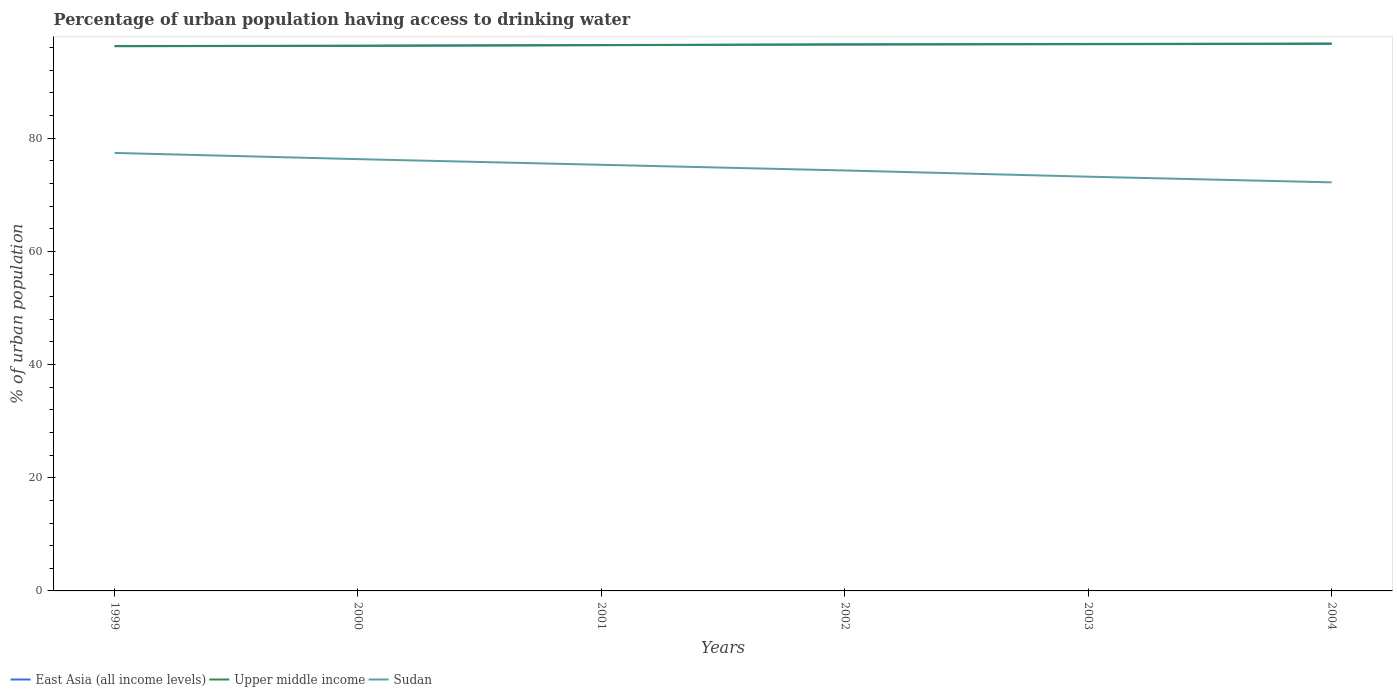How many different coloured lines are there?
Offer a very short reply. 3. Across all years, what is the maximum percentage of urban population having access to drinking water in East Asia (all income levels)?
Your answer should be very brief. 96.29. What is the total percentage of urban population having access to drinking water in East Asia (all income levels) in the graph?
Provide a succinct answer. -0.05. What is the difference between the highest and the second highest percentage of urban population having access to drinking water in Sudan?
Give a very brief answer. 5.2. What is the difference between the highest and the lowest percentage of urban population having access to drinking water in Upper middle income?
Your answer should be compact. 3. Is the percentage of urban population having access to drinking water in Sudan strictly greater than the percentage of urban population having access to drinking water in Upper middle income over the years?
Your response must be concise. Yes. How many years are there in the graph?
Provide a short and direct response. 6. How many legend labels are there?
Your response must be concise. 3. How are the legend labels stacked?
Keep it short and to the point. Horizontal. What is the title of the graph?
Your answer should be compact. Percentage of urban population having access to drinking water. Does "China" appear as one of the legend labels in the graph?
Your answer should be compact. No. What is the label or title of the X-axis?
Provide a succinct answer. Years. What is the label or title of the Y-axis?
Your answer should be very brief. % of urban population. What is the % of urban population in East Asia (all income levels) in 1999?
Make the answer very short. 96.29. What is the % of urban population in Upper middle income in 1999?
Offer a very short reply. 96.25. What is the % of urban population in Sudan in 1999?
Offer a terse response. 77.4. What is the % of urban population of East Asia (all income levels) in 2000?
Your answer should be compact. 96.35. What is the % of urban population in Upper middle income in 2000?
Make the answer very short. 96.32. What is the % of urban population of Sudan in 2000?
Your answer should be very brief. 76.3. What is the % of urban population in East Asia (all income levels) in 2001?
Make the answer very short. 96.47. What is the % of urban population in Upper middle income in 2001?
Ensure brevity in your answer.  96.43. What is the % of urban population of Sudan in 2001?
Ensure brevity in your answer.  75.3. What is the % of urban population in East Asia (all income levels) in 2002?
Your response must be concise. 96.54. What is the % of urban population of Upper middle income in 2002?
Offer a terse response. 96.6. What is the % of urban population in Sudan in 2002?
Your response must be concise. 74.3. What is the % of urban population of East Asia (all income levels) in 2003?
Keep it short and to the point. 96.61. What is the % of urban population in Upper middle income in 2003?
Give a very brief answer. 96.66. What is the % of urban population in Sudan in 2003?
Your response must be concise. 73.2. What is the % of urban population in East Asia (all income levels) in 2004?
Your answer should be very brief. 96.67. What is the % of urban population in Upper middle income in 2004?
Your answer should be compact. 96.73. What is the % of urban population of Sudan in 2004?
Give a very brief answer. 72.2. Across all years, what is the maximum % of urban population in East Asia (all income levels)?
Offer a terse response. 96.67. Across all years, what is the maximum % of urban population in Upper middle income?
Make the answer very short. 96.73. Across all years, what is the maximum % of urban population of Sudan?
Give a very brief answer. 77.4. Across all years, what is the minimum % of urban population of East Asia (all income levels)?
Your response must be concise. 96.29. Across all years, what is the minimum % of urban population in Upper middle income?
Provide a succinct answer. 96.25. Across all years, what is the minimum % of urban population in Sudan?
Provide a succinct answer. 72.2. What is the total % of urban population of East Asia (all income levels) in the graph?
Offer a very short reply. 578.93. What is the total % of urban population of Upper middle income in the graph?
Your answer should be compact. 578.99. What is the total % of urban population in Sudan in the graph?
Your answer should be compact. 448.7. What is the difference between the % of urban population of East Asia (all income levels) in 1999 and that in 2000?
Keep it short and to the point. -0.05. What is the difference between the % of urban population of Upper middle income in 1999 and that in 2000?
Give a very brief answer. -0.07. What is the difference between the % of urban population of Sudan in 1999 and that in 2000?
Keep it short and to the point. 1.1. What is the difference between the % of urban population in East Asia (all income levels) in 1999 and that in 2001?
Offer a very short reply. -0.17. What is the difference between the % of urban population in Upper middle income in 1999 and that in 2001?
Provide a succinct answer. -0.18. What is the difference between the % of urban population in East Asia (all income levels) in 1999 and that in 2002?
Your response must be concise. -0.25. What is the difference between the % of urban population of Upper middle income in 1999 and that in 2002?
Give a very brief answer. -0.35. What is the difference between the % of urban population in Sudan in 1999 and that in 2002?
Your answer should be very brief. 3.1. What is the difference between the % of urban population in East Asia (all income levels) in 1999 and that in 2003?
Provide a short and direct response. -0.31. What is the difference between the % of urban population of Upper middle income in 1999 and that in 2003?
Ensure brevity in your answer.  -0.41. What is the difference between the % of urban population in East Asia (all income levels) in 1999 and that in 2004?
Provide a succinct answer. -0.38. What is the difference between the % of urban population of Upper middle income in 1999 and that in 2004?
Your answer should be compact. -0.48. What is the difference between the % of urban population of East Asia (all income levels) in 2000 and that in 2001?
Offer a terse response. -0.12. What is the difference between the % of urban population in Upper middle income in 2000 and that in 2001?
Keep it short and to the point. -0.11. What is the difference between the % of urban population in Sudan in 2000 and that in 2001?
Provide a succinct answer. 1. What is the difference between the % of urban population in East Asia (all income levels) in 2000 and that in 2002?
Your answer should be compact. -0.2. What is the difference between the % of urban population in Upper middle income in 2000 and that in 2002?
Your answer should be compact. -0.27. What is the difference between the % of urban population in Sudan in 2000 and that in 2002?
Offer a terse response. 2. What is the difference between the % of urban population in East Asia (all income levels) in 2000 and that in 2003?
Offer a terse response. -0.26. What is the difference between the % of urban population of Upper middle income in 2000 and that in 2003?
Offer a terse response. -0.34. What is the difference between the % of urban population of East Asia (all income levels) in 2000 and that in 2004?
Offer a very short reply. -0.33. What is the difference between the % of urban population in Upper middle income in 2000 and that in 2004?
Give a very brief answer. -0.41. What is the difference between the % of urban population of Sudan in 2000 and that in 2004?
Offer a terse response. 4.1. What is the difference between the % of urban population of East Asia (all income levels) in 2001 and that in 2002?
Give a very brief answer. -0.07. What is the difference between the % of urban population in Upper middle income in 2001 and that in 2002?
Offer a very short reply. -0.17. What is the difference between the % of urban population in Sudan in 2001 and that in 2002?
Your answer should be very brief. 1. What is the difference between the % of urban population of East Asia (all income levels) in 2001 and that in 2003?
Make the answer very short. -0.14. What is the difference between the % of urban population of Upper middle income in 2001 and that in 2003?
Ensure brevity in your answer.  -0.23. What is the difference between the % of urban population of East Asia (all income levels) in 2001 and that in 2004?
Your response must be concise. -0.2. What is the difference between the % of urban population in Upper middle income in 2001 and that in 2004?
Provide a succinct answer. -0.3. What is the difference between the % of urban population in East Asia (all income levels) in 2002 and that in 2003?
Keep it short and to the point. -0.07. What is the difference between the % of urban population in Upper middle income in 2002 and that in 2003?
Ensure brevity in your answer.  -0.06. What is the difference between the % of urban population in East Asia (all income levels) in 2002 and that in 2004?
Offer a terse response. -0.13. What is the difference between the % of urban population of Upper middle income in 2002 and that in 2004?
Provide a succinct answer. -0.14. What is the difference between the % of urban population in East Asia (all income levels) in 2003 and that in 2004?
Give a very brief answer. -0.07. What is the difference between the % of urban population of Upper middle income in 2003 and that in 2004?
Offer a terse response. -0.07. What is the difference between the % of urban population of East Asia (all income levels) in 1999 and the % of urban population of Upper middle income in 2000?
Your answer should be very brief. -0.03. What is the difference between the % of urban population of East Asia (all income levels) in 1999 and the % of urban population of Sudan in 2000?
Your answer should be very brief. 20. What is the difference between the % of urban population of Upper middle income in 1999 and the % of urban population of Sudan in 2000?
Provide a succinct answer. 19.95. What is the difference between the % of urban population of East Asia (all income levels) in 1999 and the % of urban population of Upper middle income in 2001?
Ensure brevity in your answer.  -0.13. What is the difference between the % of urban population of East Asia (all income levels) in 1999 and the % of urban population of Sudan in 2001?
Your response must be concise. 21. What is the difference between the % of urban population of Upper middle income in 1999 and the % of urban population of Sudan in 2001?
Your answer should be compact. 20.95. What is the difference between the % of urban population of East Asia (all income levels) in 1999 and the % of urban population of Upper middle income in 2002?
Provide a short and direct response. -0.3. What is the difference between the % of urban population of East Asia (all income levels) in 1999 and the % of urban population of Sudan in 2002?
Your response must be concise. 22. What is the difference between the % of urban population in Upper middle income in 1999 and the % of urban population in Sudan in 2002?
Provide a short and direct response. 21.95. What is the difference between the % of urban population in East Asia (all income levels) in 1999 and the % of urban population in Upper middle income in 2003?
Make the answer very short. -0.37. What is the difference between the % of urban population of East Asia (all income levels) in 1999 and the % of urban population of Sudan in 2003?
Your answer should be very brief. 23.09. What is the difference between the % of urban population of Upper middle income in 1999 and the % of urban population of Sudan in 2003?
Make the answer very short. 23.05. What is the difference between the % of urban population in East Asia (all income levels) in 1999 and the % of urban population in Upper middle income in 2004?
Your answer should be compact. -0.44. What is the difference between the % of urban population in East Asia (all income levels) in 1999 and the % of urban population in Sudan in 2004?
Your answer should be very brief. 24.09. What is the difference between the % of urban population in Upper middle income in 1999 and the % of urban population in Sudan in 2004?
Your answer should be very brief. 24.05. What is the difference between the % of urban population of East Asia (all income levels) in 2000 and the % of urban population of Upper middle income in 2001?
Make the answer very short. -0.08. What is the difference between the % of urban population in East Asia (all income levels) in 2000 and the % of urban population in Sudan in 2001?
Make the answer very short. 21.05. What is the difference between the % of urban population in Upper middle income in 2000 and the % of urban population in Sudan in 2001?
Give a very brief answer. 21.02. What is the difference between the % of urban population of East Asia (all income levels) in 2000 and the % of urban population of Upper middle income in 2002?
Keep it short and to the point. -0.25. What is the difference between the % of urban population of East Asia (all income levels) in 2000 and the % of urban population of Sudan in 2002?
Offer a very short reply. 22.05. What is the difference between the % of urban population of Upper middle income in 2000 and the % of urban population of Sudan in 2002?
Your answer should be compact. 22.02. What is the difference between the % of urban population in East Asia (all income levels) in 2000 and the % of urban population in Upper middle income in 2003?
Your answer should be very brief. -0.32. What is the difference between the % of urban population of East Asia (all income levels) in 2000 and the % of urban population of Sudan in 2003?
Offer a very short reply. 23.15. What is the difference between the % of urban population of Upper middle income in 2000 and the % of urban population of Sudan in 2003?
Your answer should be compact. 23.12. What is the difference between the % of urban population in East Asia (all income levels) in 2000 and the % of urban population in Upper middle income in 2004?
Ensure brevity in your answer.  -0.39. What is the difference between the % of urban population of East Asia (all income levels) in 2000 and the % of urban population of Sudan in 2004?
Ensure brevity in your answer.  24.15. What is the difference between the % of urban population in Upper middle income in 2000 and the % of urban population in Sudan in 2004?
Keep it short and to the point. 24.12. What is the difference between the % of urban population of East Asia (all income levels) in 2001 and the % of urban population of Upper middle income in 2002?
Provide a succinct answer. -0.13. What is the difference between the % of urban population in East Asia (all income levels) in 2001 and the % of urban population in Sudan in 2002?
Your answer should be compact. 22.17. What is the difference between the % of urban population in Upper middle income in 2001 and the % of urban population in Sudan in 2002?
Make the answer very short. 22.13. What is the difference between the % of urban population of East Asia (all income levels) in 2001 and the % of urban population of Upper middle income in 2003?
Provide a succinct answer. -0.19. What is the difference between the % of urban population of East Asia (all income levels) in 2001 and the % of urban population of Sudan in 2003?
Provide a short and direct response. 23.27. What is the difference between the % of urban population of Upper middle income in 2001 and the % of urban population of Sudan in 2003?
Your response must be concise. 23.23. What is the difference between the % of urban population of East Asia (all income levels) in 2001 and the % of urban population of Upper middle income in 2004?
Offer a very short reply. -0.26. What is the difference between the % of urban population in East Asia (all income levels) in 2001 and the % of urban population in Sudan in 2004?
Provide a succinct answer. 24.27. What is the difference between the % of urban population in Upper middle income in 2001 and the % of urban population in Sudan in 2004?
Offer a very short reply. 24.23. What is the difference between the % of urban population in East Asia (all income levels) in 2002 and the % of urban population in Upper middle income in 2003?
Your answer should be very brief. -0.12. What is the difference between the % of urban population of East Asia (all income levels) in 2002 and the % of urban population of Sudan in 2003?
Ensure brevity in your answer.  23.34. What is the difference between the % of urban population in Upper middle income in 2002 and the % of urban population in Sudan in 2003?
Offer a very short reply. 23.4. What is the difference between the % of urban population of East Asia (all income levels) in 2002 and the % of urban population of Upper middle income in 2004?
Give a very brief answer. -0.19. What is the difference between the % of urban population in East Asia (all income levels) in 2002 and the % of urban population in Sudan in 2004?
Give a very brief answer. 24.34. What is the difference between the % of urban population of Upper middle income in 2002 and the % of urban population of Sudan in 2004?
Make the answer very short. 24.4. What is the difference between the % of urban population of East Asia (all income levels) in 2003 and the % of urban population of Upper middle income in 2004?
Provide a short and direct response. -0.13. What is the difference between the % of urban population in East Asia (all income levels) in 2003 and the % of urban population in Sudan in 2004?
Give a very brief answer. 24.41. What is the difference between the % of urban population of Upper middle income in 2003 and the % of urban population of Sudan in 2004?
Give a very brief answer. 24.46. What is the average % of urban population in East Asia (all income levels) per year?
Give a very brief answer. 96.49. What is the average % of urban population of Upper middle income per year?
Your answer should be very brief. 96.5. What is the average % of urban population of Sudan per year?
Keep it short and to the point. 74.78. In the year 1999, what is the difference between the % of urban population of East Asia (all income levels) and % of urban population of Upper middle income?
Make the answer very short. 0.05. In the year 1999, what is the difference between the % of urban population of East Asia (all income levels) and % of urban population of Sudan?
Your response must be concise. 18.89. In the year 1999, what is the difference between the % of urban population in Upper middle income and % of urban population in Sudan?
Ensure brevity in your answer.  18.85. In the year 2000, what is the difference between the % of urban population in East Asia (all income levels) and % of urban population in Upper middle income?
Your answer should be very brief. 0.02. In the year 2000, what is the difference between the % of urban population in East Asia (all income levels) and % of urban population in Sudan?
Provide a short and direct response. 20.05. In the year 2000, what is the difference between the % of urban population of Upper middle income and % of urban population of Sudan?
Give a very brief answer. 20.02. In the year 2001, what is the difference between the % of urban population of East Asia (all income levels) and % of urban population of Upper middle income?
Your answer should be very brief. 0.04. In the year 2001, what is the difference between the % of urban population in East Asia (all income levels) and % of urban population in Sudan?
Give a very brief answer. 21.17. In the year 2001, what is the difference between the % of urban population of Upper middle income and % of urban population of Sudan?
Offer a terse response. 21.13. In the year 2002, what is the difference between the % of urban population of East Asia (all income levels) and % of urban population of Upper middle income?
Your answer should be very brief. -0.06. In the year 2002, what is the difference between the % of urban population in East Asia (all income levels) and % of urban population in Sudan?
Make the answer very short. 22.24. In the year 2002, what is the difference between the % of urban population in Upper middle income and % of urban population in Sudan?
Ensure brevity in your answer.  22.3. In the year 2003, what is the difference between the % of urban population in East Asia (all income levels) and % of urban population in Upper middle income?
Your answer should be compact. -0.05. In the year 2003, what is the difference between the % of urban population of East Asia (all income levels) and % of urban population of Sudan?
Offer a terse response. 23.41. In the year 2003, what is the difference between the % of urban population in Upper middle income and % of urban population in Sudan?
Ensure brevity in your answer.  23.46. In the year 2004, what is the difference between the % of urban population of East Asia (all income levels) and % of urban population of Upper middle income?
Provide a short and direct response. -0.06. In the year 2004, what is the difference between the % of urban population of East Asia (all income levels) and % of urban population of Sudan?
Give a very brief answer. 24.47. In the year 2004, what is the difference between the % of urban population of Upper middle income and % of urban population of Sudan?
Provide a short and direct response. 24.53. What is the ratio of the % of urban population of Sudan in 1999 to that in 2000?
Offer a terse response. 1.01. What is the ratio of the % of urban population of East Asia (all income levels) in 1999 to that in 2001?
Offer a terse response. 1. What is the ratio of the % of urban population of Upper middle income in 1999 to that in 2001?
Make the answer very short. 1. What is the ratio of the % of urban population of Sudan in 1999 to that in 2001?
Your response must be concise. 1.03. What is the ratio of the % of urban population in East Asia (all income levels) in 1999 to that in 2002?
Offer a very short reply. 1. What is the ratio of the % of urban population of Sudan in 1999 to that in 2002?
Your answer should be compact. 1.04. What is the ratio of the % of urban population in Sudan in 1999 to that in 2003?
Make the answer very short. 1.06. What is the ratio of the % of urban population in Upper middle income in 1999 to that in 2004?
Your answer should be compact. 0.99. What is the ratio of the % of urban population in Sudan in 1999 to that in 2004?
Provide a short and direct response. 1.07. What is the ratio of the % of urban population in East Asia (all income levels) in 2000 to that in 2001?
Keep it short and to the point. 1. What is the ratio of the % of urban population of Sudan in 2000 to that in 2001?
Your answer should be very brief. 1.01. What is the ratio of the % of urban population of Sudan in 2000 to that in 2002?
Keep it short and to the point. 1.03. What is the ratio of the % of urban population of East Asia (all income levels) in 2000 to that in 2003?
Make the answer very short. 1. What is the ratio of the % of urban population in Sudan in 2000 to that in 2003?
Offer a very short reply. 1.04. What is the ratio of the % of urban population in Sudan in 2000 to that in 2004?
Provide a succinct answer. 1.06. What is the ratio of the % of urban population in East Asia (all income levels) in 2001 to that in 2002?
Your answer should be very brief. 1. What is the ratio of the % of urban population of Sudan in 2001 to that in 2002?
Provide a short and direct response. 1.01. What is the ratio of the % of urban population of East Asia (all income levels) in 2001 to that in 2003?
Provide a succinct answer. 1. What is the ratio of the % of urban population in Sudan in 2001 to that in 2003?
Offer a very short reply. 1.03. What is the ratio of the % of urban population in Sudan in 2001 to that in 2004?
Give a very brief answer. 1.04. What is the ratio of the % of urban population of East Asia (all income levels) in 2002 to that in 2003?
Offer a very short reply. 1. What is the ratio of the % of urban population of East Asia (all income levels) in 2002 to that in 2004?
Ensure brevity in your answer.  1. What is the ratio of the % of urban population in Upper middle income in 2002 to that in 2004?
Keep it short and to the point. 1. What is the ratio of the % of urban population in Sudan in 2002 to that in 2004?
Give a very brief answer. 1.03. What is the ratio of the % of urban population of Upper middle income in 2003 to that in 2004?
Offer a terse response. 1. What is the ratio of the % of urban population of Sudan in 2003 to that in 2004?
Offer a terse response. 1.01. What is the difference between the highest and the second highest % of urban population in East Asia (all income levels)?
Offer a very short reply. 0.07. What is the difference between the highest and the second highest % of urban population of Upper middle income?
Your response must be concise. 0.07. What is the difference between the highest and the second highest % of urban population of Sudan?
Provide a short and direct response. 1.1. What is the difference between the highest and the lowest % of urban population of East Asia (all income levels)?
Ensure brevity in your answer.  0.38. What is the difference between the highest and the lowest % of urban population of Upper middle income?
Ensure brevity in your answer.  0.48. 